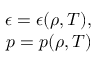Convert formula to latex. <formula><loc_0><loc_0><loc_500><loc_500>\begin{array} { r } { \epsilon = \epsilon ( \rho , T ) , } \\ { p = p ( \rho , T ) } \end{array}</formula> 